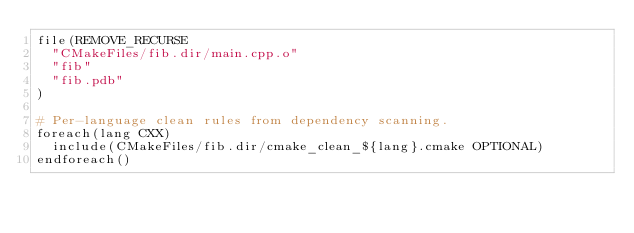<code> <loc_0><loc_0><loc_500><loc_500><_CMake_>file(REMOVE_RECURSE
  "CMakeFiles/fib.dir/main.cpp.o"
  "fib"
  "fib.pdb"
)

# Per-language clean rules from dependency scanning.
foreach(lang CXX)
  include(CMakeFiles/fib.dir/cmake_clean_${lang}.cmake OPTIONAL)
endforeach()
</code> 